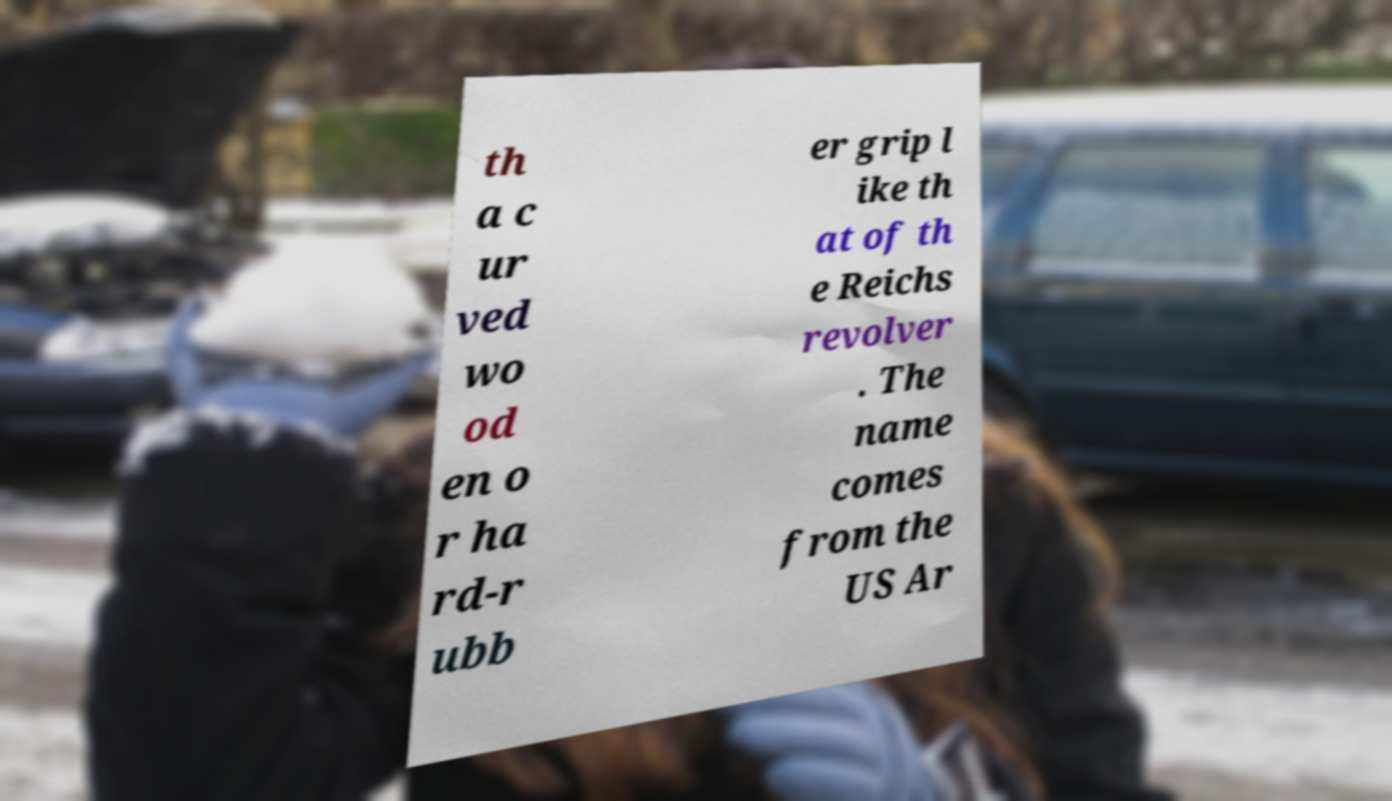Could you assist in decoding the text presented in this image and type it out clearly? th a c ur ved wo od en o r ha rd-r ubb er grip l ike th at of th e Reichs revolver . The name comes from the US Ar 